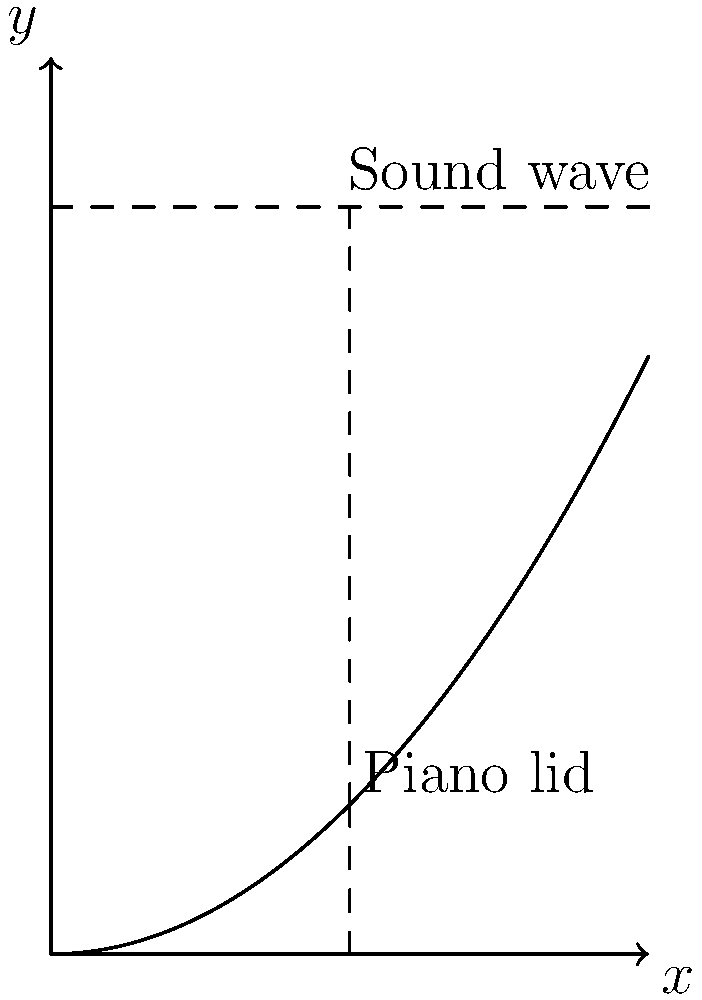As a classical concert pianist, you're intrigued by the acoustics of your piano. The lid of your grand piano can be modeled by the function $y = 0.5x^2$, where $x$ is the horizontal distance from the hinge and $y$ is the height. A sound wave travels horizontally at a height of 2.5 units above the base. At what horizontal distance $x$ from the hinge should the sound wave hit the lid to maximize the angle of reflection and thus optimize sound projection to the audience? To solve this optimization problem, we can follow these steps:

1) The normal line to the curve at the point of reflection bisects the angle between the incident sound wave and the reflected wave.

2) The slope of the tangent line to the curve $y = 0.5x^2$ at any point is given by the derivative: $y' = x$.

3) The normal line is perpendicular to the tangent line, so its slope is the negative reciprocal of the tangent line's slope: $-\frac{1}{x}$.

4) The equation of the normal line passing through the point $(x, 0.5x^2)$ is:
   $y - 0.5x^2 = -\frac{1}{x}(t - x)$, where $t$ is the x-coordinate.

5) This normal line should pass through the point $(x, 2.5)$ where it intersects the sound wave. Substituting this point into the equation of the normal line:
   $2.5 - 0.5x^2 = -\frac{1}{x}(x - x) = 0$

6) Simplifying: $2.5 = 0.5x^2$

7) Solving for $x$: $x^2 = 5$, so $x = \sqrt{5} \approx 2.236$

Therefore, the sound wave should hit the lid at a horizontal distance of $\sqrt{5}$ units from the hinge to maximize the angle of reflection and optimize sound projection.
Answer: $\sqrt{5}$ units 